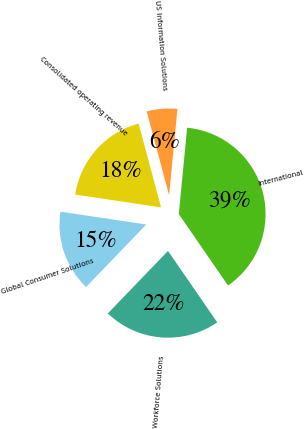Convert chart. <chart><loc_0><loc_0><loc_500><loc_500><pie_chart><fcel>US Information Solutions<fcel>International<fcel>Workforce Solutions<fcel>Global Consumer Solutions<fcel>Consolidated operating revenue<nl><fcel>5.69%<fcel>38.86%<fcel>21.8%<fcel>15.17%<fcel>18.48%<nl></chart> 